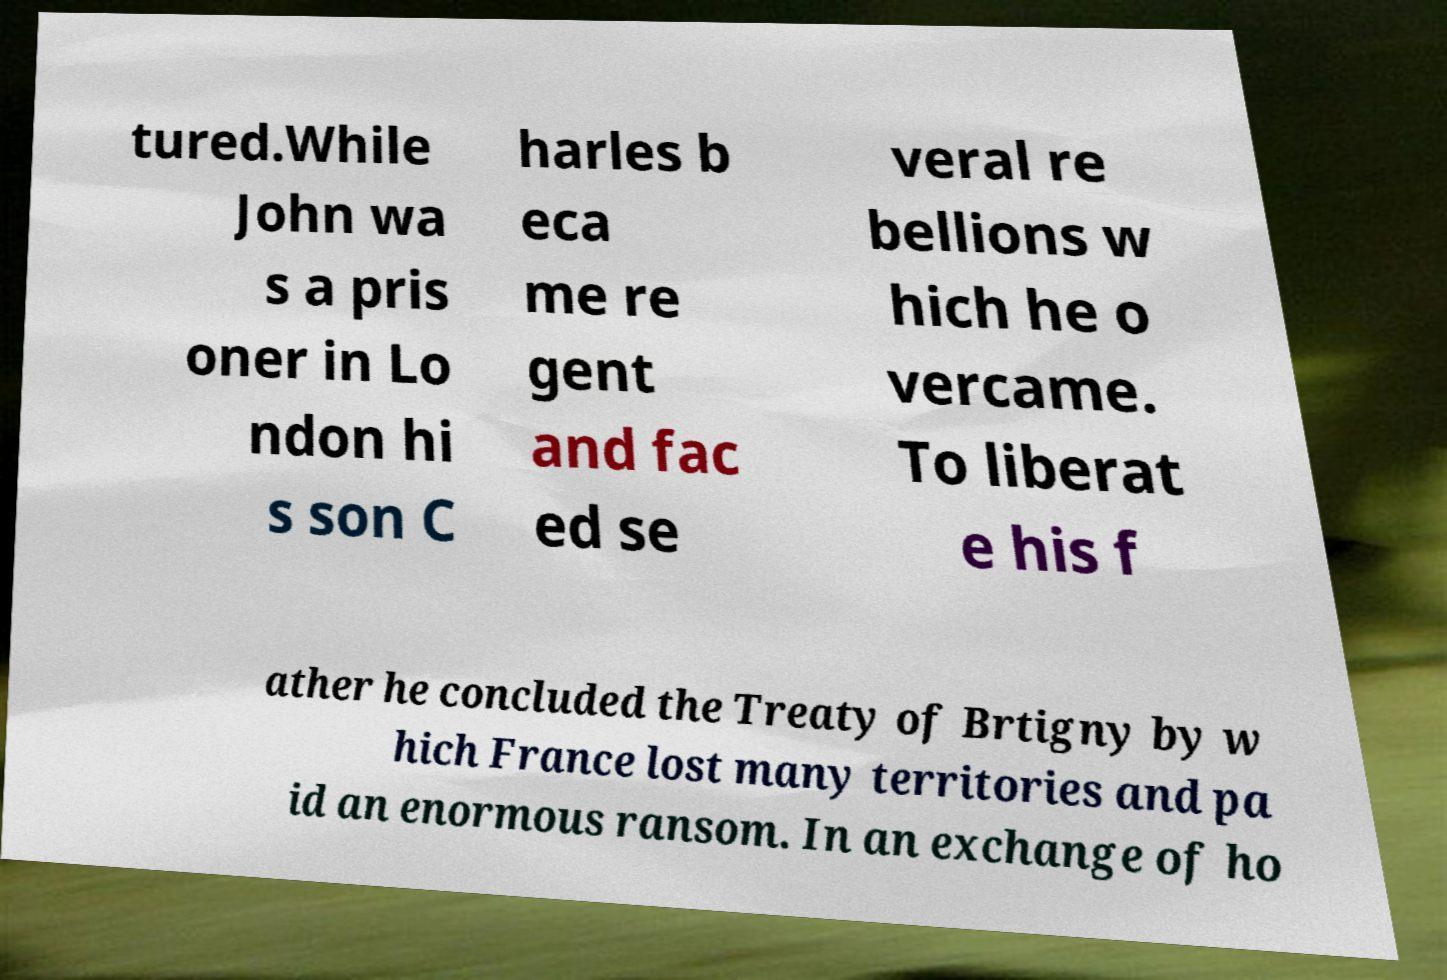There's text embedded in this image that I need extracted. Can you transcribe it verbatim? tured.While John wa s a pris oner in Lo ndon hi s son C harles b eca me re gent and fac ed se veral re bellions w hich he o vercame. To liberat e his f ather he concluded the Treaty of Brtigny by w hich France lost many territories and pa id an enormous ransom. In an exchange of ho 